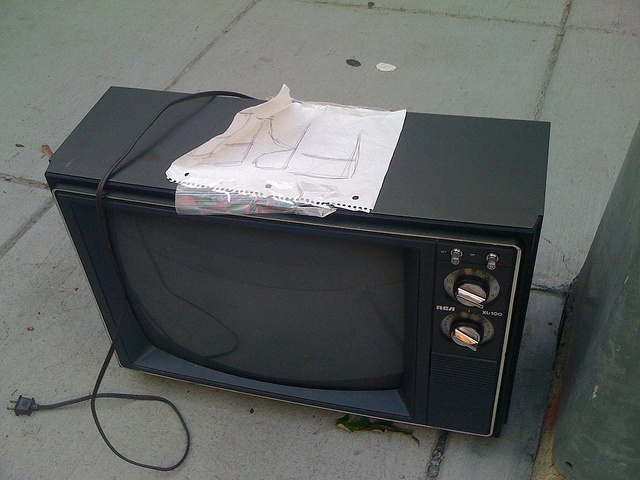Describe the objects in this image and their specific colors. I can see a tv in gray, black, lightgray, and purple tones in this image. 